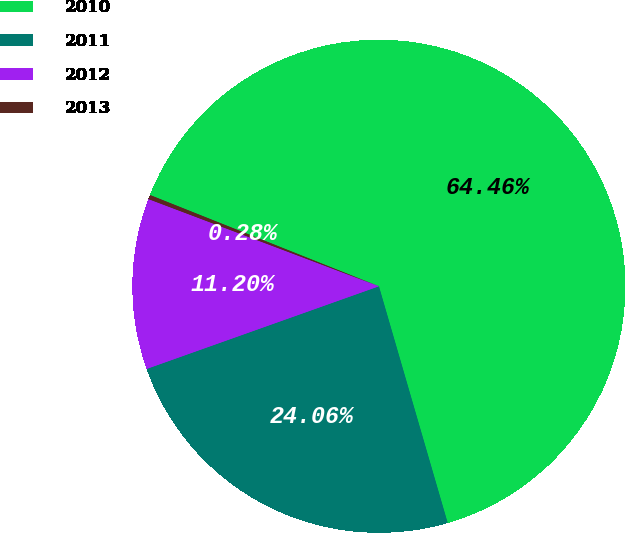Convert chart to OTSL. <chart><loc_0><loc_0><loc_500><loc_500><pie_chart><fcel>2010<fcel>2011<fcel>2012<fcel>2013<nl><fcel>64.46%<fcel>24.06%<fcel>11.2%<fcel>0.28%<nl></chart> 